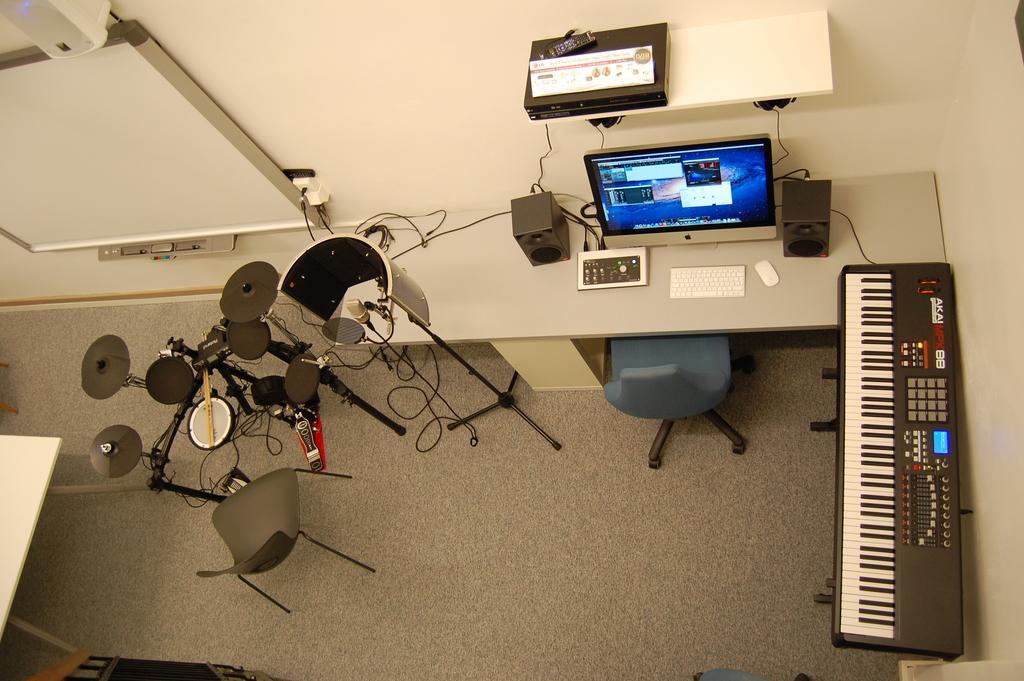Describe this image in one or two sentences. In this image we can see the aerial view of a room. In the aerial view there are desktop, speakers, remote, switch board, cables, chair, musical instrument and pipelines. 